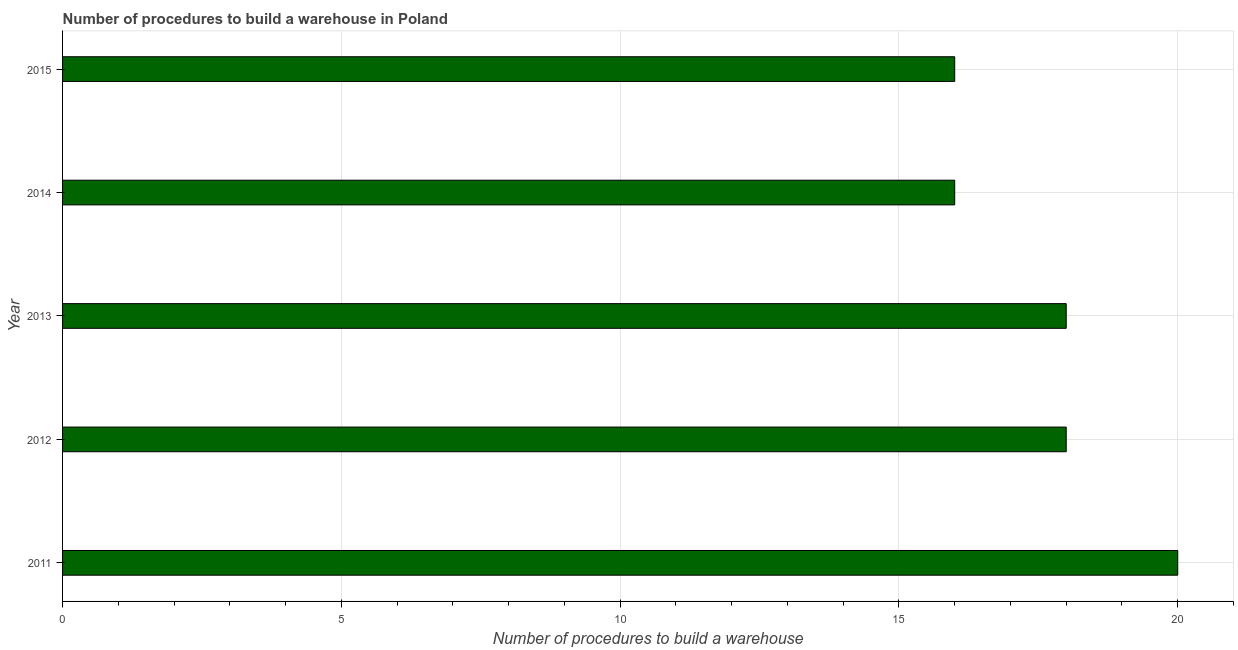What is the title of the graph?
Keep it short and to the point. Number of procedures to build a warehouse in Poland. What is the label or title of the X-axis?
Your response must be concise. Number of procedures to build a warehouse. What is the average number of procedures to build a warehouse per year?
Your response must be concise. 17. In how many years, is the number of procedures to build a warehouse greater than 5 ?
Offer a terse response. 5. What is the difference between the highest and the second highest number of procedures to build a warehouse?
Your answer should be compact. 2. Is the sum of the number of procedures to build a warehouse in 2012 and 2015 greater than the maximum number of procedures to build a warehouse across all years?
Ensure brevity in your answer.  Yes. What is the difference between the highest and the lowest number of procedures to build a warehouse?
Give a very brief answer. 4. Are all the bars in the graph horizontal?
Offer a terse response. Yes. How many years are there in the graph?
Give a very brief answer. 5. What is the Number of procedures to build a warehouse in 2012?
Make the answer very short. 18. What is the Number of procedures to build a warehouse of 2013?
Offer a very short reply. 18. What is the Number of procedures to build a warehouse in 2014?
Your answer should be very brief. 16. What is the difference between the Number of procedures to build a warehouse in 2011 and 2012?
Provide a succinct answer. 2. What is the difference between the Number of procedures to build a warehouse in 2011 and 2014?
Provide a short and direct response. 4. What is the difference between the Number of procedures to build a warehouse in 2011 and 2015?
Your answer should be compact. 4. What is the difference between the Number of procedures to build a warehouse in 2012 and 2013?
Provide a succinct answer. 0. What is the difference between the Number of procedures to build a warehouse in 2013 and 2014?
Make the answer very short. 2. What is the difference between the Number of procedures to build a warehouse in 2014 and 2015?
Give a very brief answer. 0. What is the ratio of the Number of procedures to build a warehouse in 2011 to that in 2012?
Keep it short and to the point. 1.11. What is the ratio of the Number of procedures to build a warehouse in 2011 to that in 2013?
Make the answer very short. 1.11. What is the ratio of the Number of procedures to build a warehouse in 2011 to that in 2014?
Your answer should be compact. 1.25. What is the ratio of the Number of procedures to build a warehouse in 2012 to that in 2013?
Your answer should be compact. 1. What is the ratio of the Number of procedures to build a warehouse in 2012 to that in 2014?
Ensure brevity in your answer.  1.12. What is the ratio of the Number of procedures to build a warehouse in 2012 to that in 2015?
Keep it short and to the point. 1.12. What is the ratio of the Number of procedures to build a warehouse in 2014 to that in 2015?
Offer a very short reply. 1. 